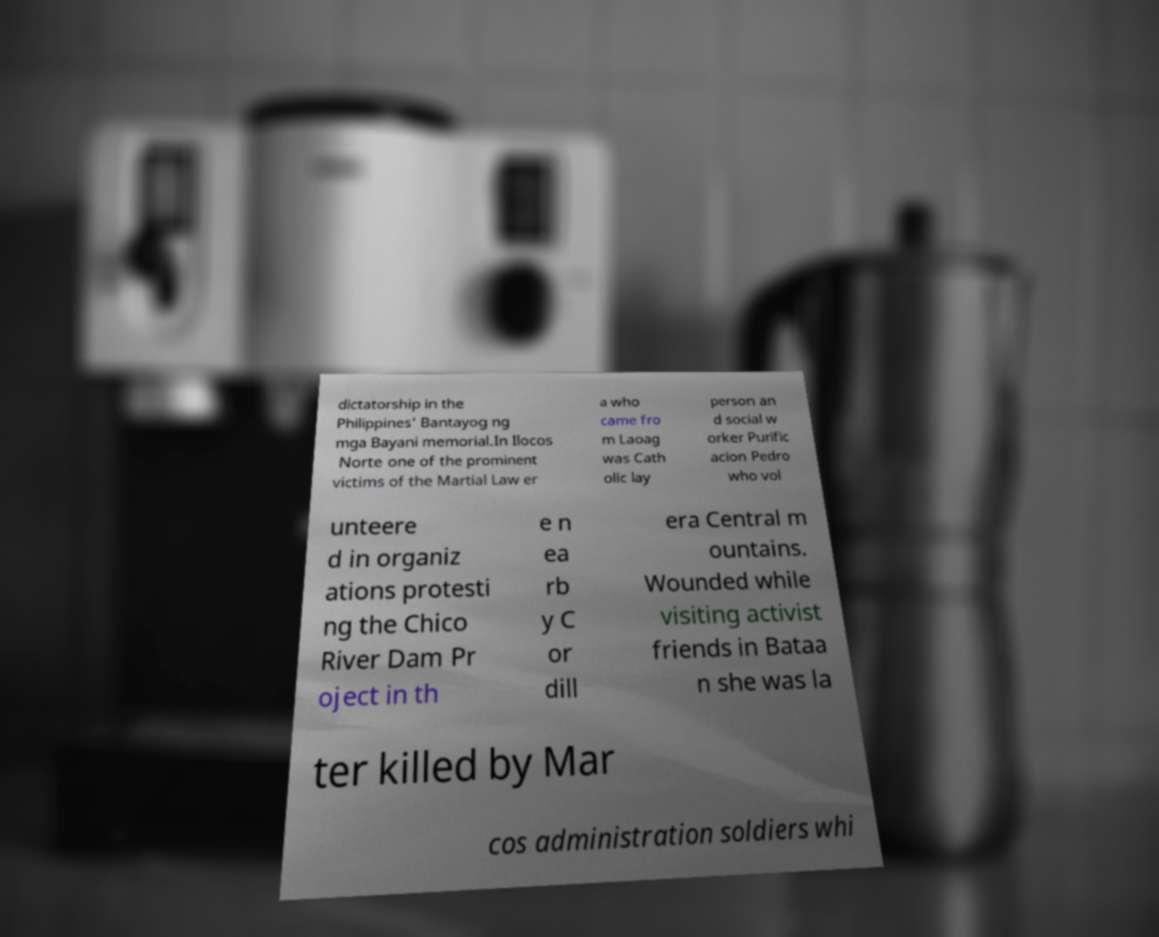Please identify and transcribe the text found in this image. dictatorship in the Philippines' Bantayog ng mga Bayani memorial.In Ilocos Norte one of the prominent victims of the Martial Law er a who came fro m Laoag was Cath olic lay person an d social w orker Purific acion Pedro who vol unteere d in organiz ations protesti ng the Chico River Dam Pr oject in th e n ea rb y C or dill era Central m ountains. Wounded while visiting activist friends in Bataa n she was la ter killed by Mar cos administration soldiers whi 